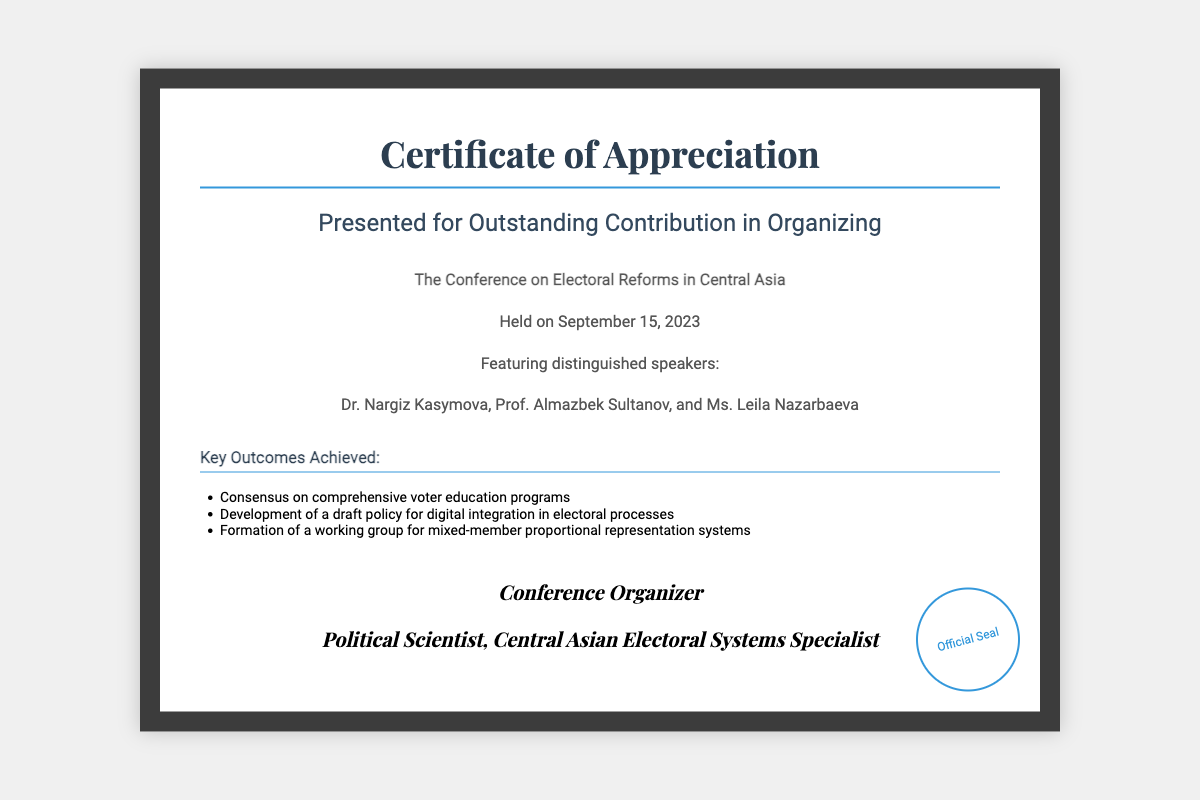What is the title of the conference? The title of the conference is mentioned prominently within the content of the document.
Answer: The Conference on Electoral Reforms in Central Asia When was the conference held? The date of the conference is stated clearly in the content section.
Answer: September 15, 2023 Who is one of the guest speakers? The document lists distinguished speakers, and any of them can be the answer.
Answer: Dr. Nargiz Kasymova What is one key outcome achieved from the conference? The main outcomes are listed in the outcomes section of the document.
Answer: Consensus on comprehensive voter education programs How many guest speakers are mentioned? The document specifies the number of guest speakers included in the list.
Answer: Three 